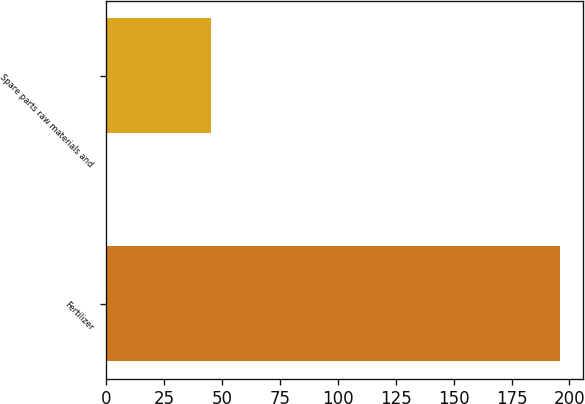Convert chart. <chart><loc_0><loc_0><loc_500><loc_500><bar_chart><fcel>Fertilizer<fcel>Spare parts raw materials and<nl><fcel>196.1<fcel>45.2<nl></chart> 